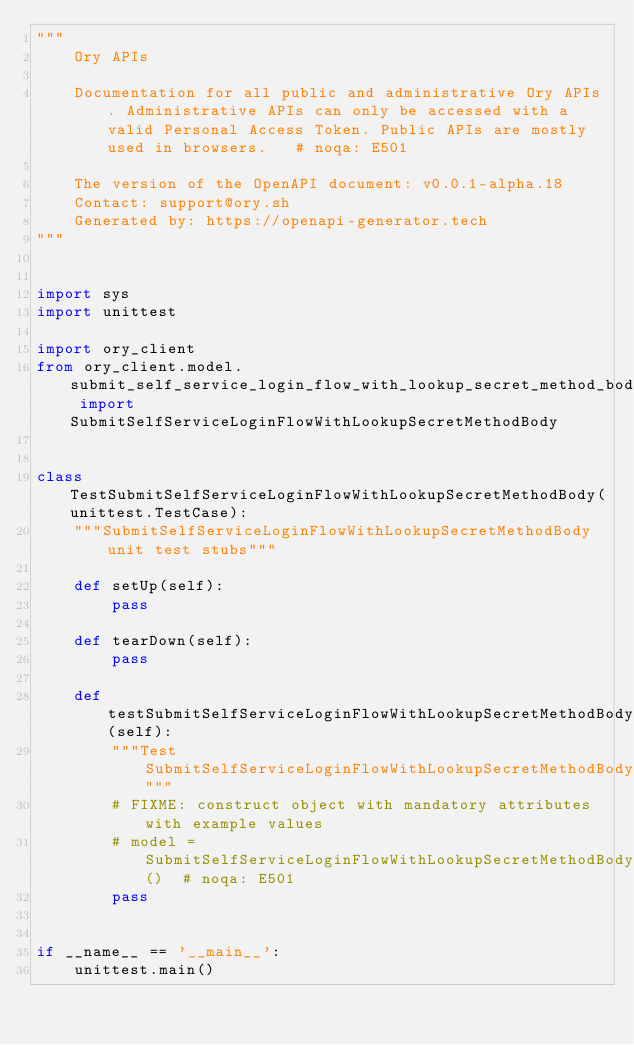Convert code to text. <code><loc_0><loc_0><loc_500><loc_500><_Python_>"""
    Ory APIs

    Documentation for all public and administrative Ory APIs. Administrative APIs can only be accessed with a valid Personal Access Token. Public APIs are mostly used in browsers.   # noqa: E501

    The version of the OpenAPI document: v0.0.1-alpha.18
    Contact: support@ory.sh
    Generated by: https://openapi-generator.tech
"""


import sys
import unittest

import ory_client
from ory_client.model.submit_self_service_login_flow_with_lookup_secret_method_body import SubmitSelfServiceLoginFlowWithLookupSecretMethodBody


class TestSubmitSelfServiceLoginFlowWithLookupSecretMethodBody(unittest.TestCase):
    """SubmitSelfServiceLoginFlowWithLookupSecretMethodBody unit test stubs"""

    def setUp(self):
        pass

    def tearDown(self):
        pass

    def testSubmitSelfServiceLoginFlowWithLookupSecretMethodBody(self):
        """Test SubmitSelfServiceLoginFlowWithLookupSecretMethodBody"""
        # FIXME: construct object with mandatory attributes with example values
        # model = SubmitSelfServiceLoginFlowWithLookupSecretMethodBody()  # noqa: E501
        pass


if __name__ == '__main__':
    unittest.main()
</code> 